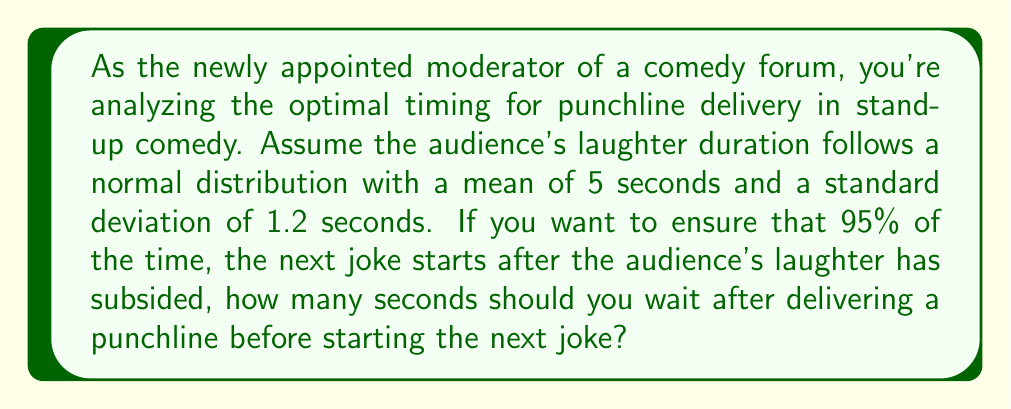Can you solve this math problem? To solve this problem, we need to use the properties of the normal distribution and the concept of z-scores.

1. We're given that the laughter duration follows a normal distribution with:
   Mean (μ) = 5 seconds
   Standard deviation (σ) = 1.2 seconds

2. We want to find the time that covers 95% of the laughter durations. This corresponds to the 95th percentile of the distribution.

3. In a normal distribution, the area between the mean and a z-score of 1.645 covers 45% of the distribution. Since we want 95% (which is 50% + 45%), we'll use this z-score.

4. The formula for converting a z-score to an x-value is:
   $$ x = μ + (z * σ) $$

5. Plugging in our values:
   $$ x = 5 + (1.645 * 1.2) $$

6. Calculating:
   $$ x = 5 + 1.974 = 6.974 $$

7. Rounding up to ensure we cover at least 95% of laughter durations:
   x ≈ 7 seconds

Therefore, you should wait approximately 7 seconds after delivering a punchline before starting the next joke to ensure that 95% of the time, the audience's laughter has subsided.
Answer: 7 seconds 